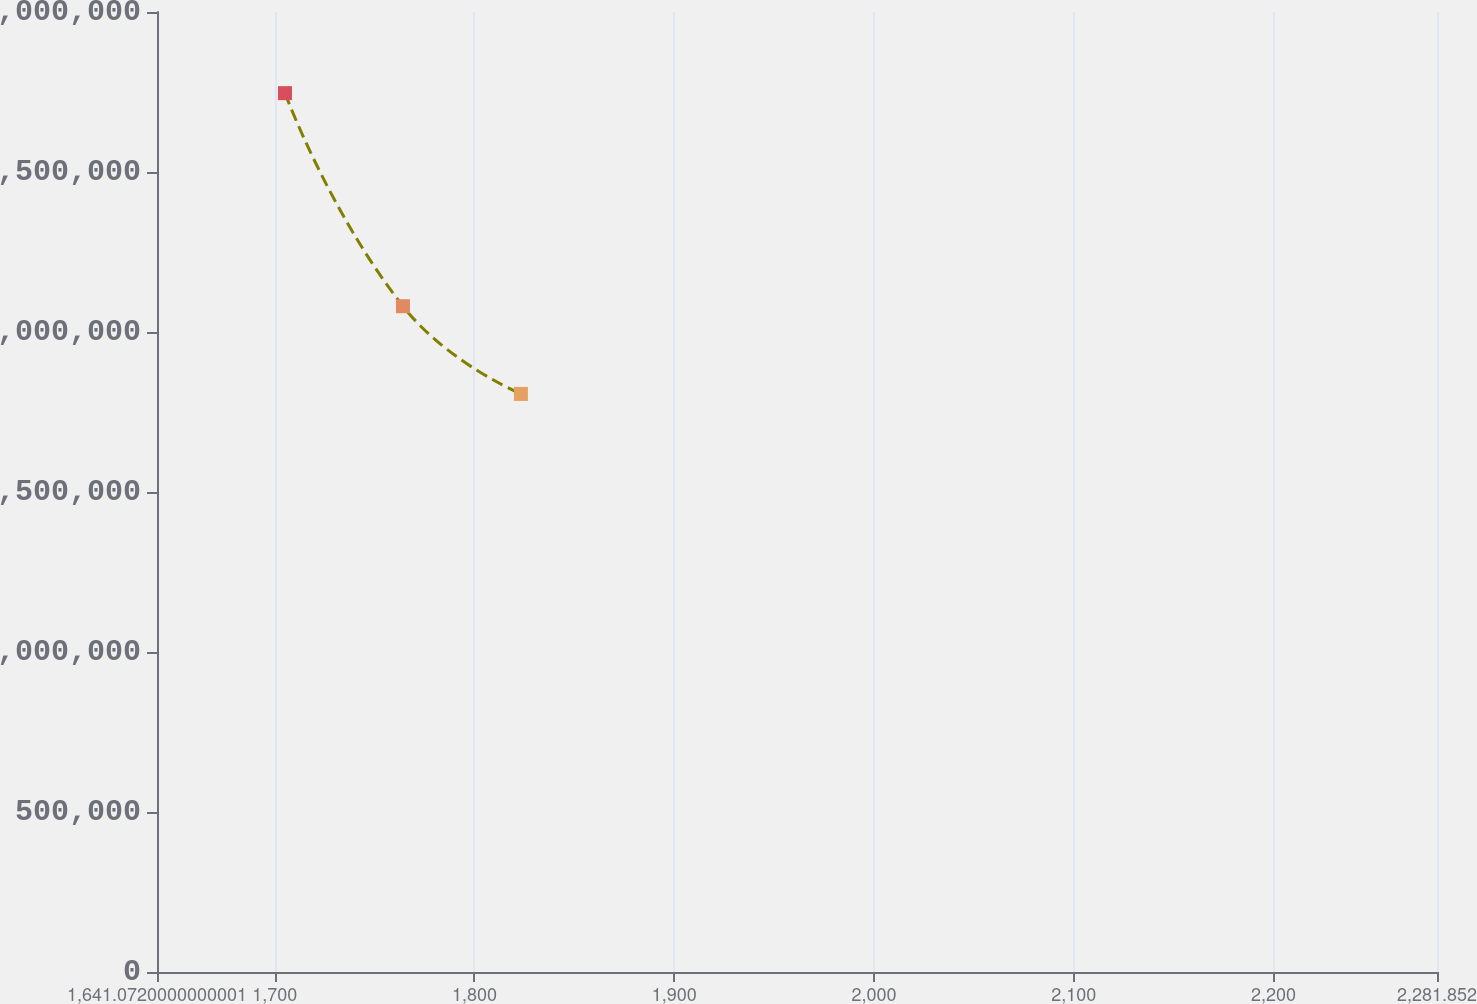Convert chart to OTSL. <chart><loc_0><loc_0><loc_500><loc_500><line_chart><ecel><fcel>Unnamed: 1<nl><fcel>1705.15<fcel>2.74643e+06<nl><fcel>1764.2<fcel>2.08056e+06<nl><fcel>1823.25<fcel>1.80653e+06<nl><fcel>2286.88<fcel>415062<nl><fcel>2345.93<fcel>6112.49<nl></chart> 